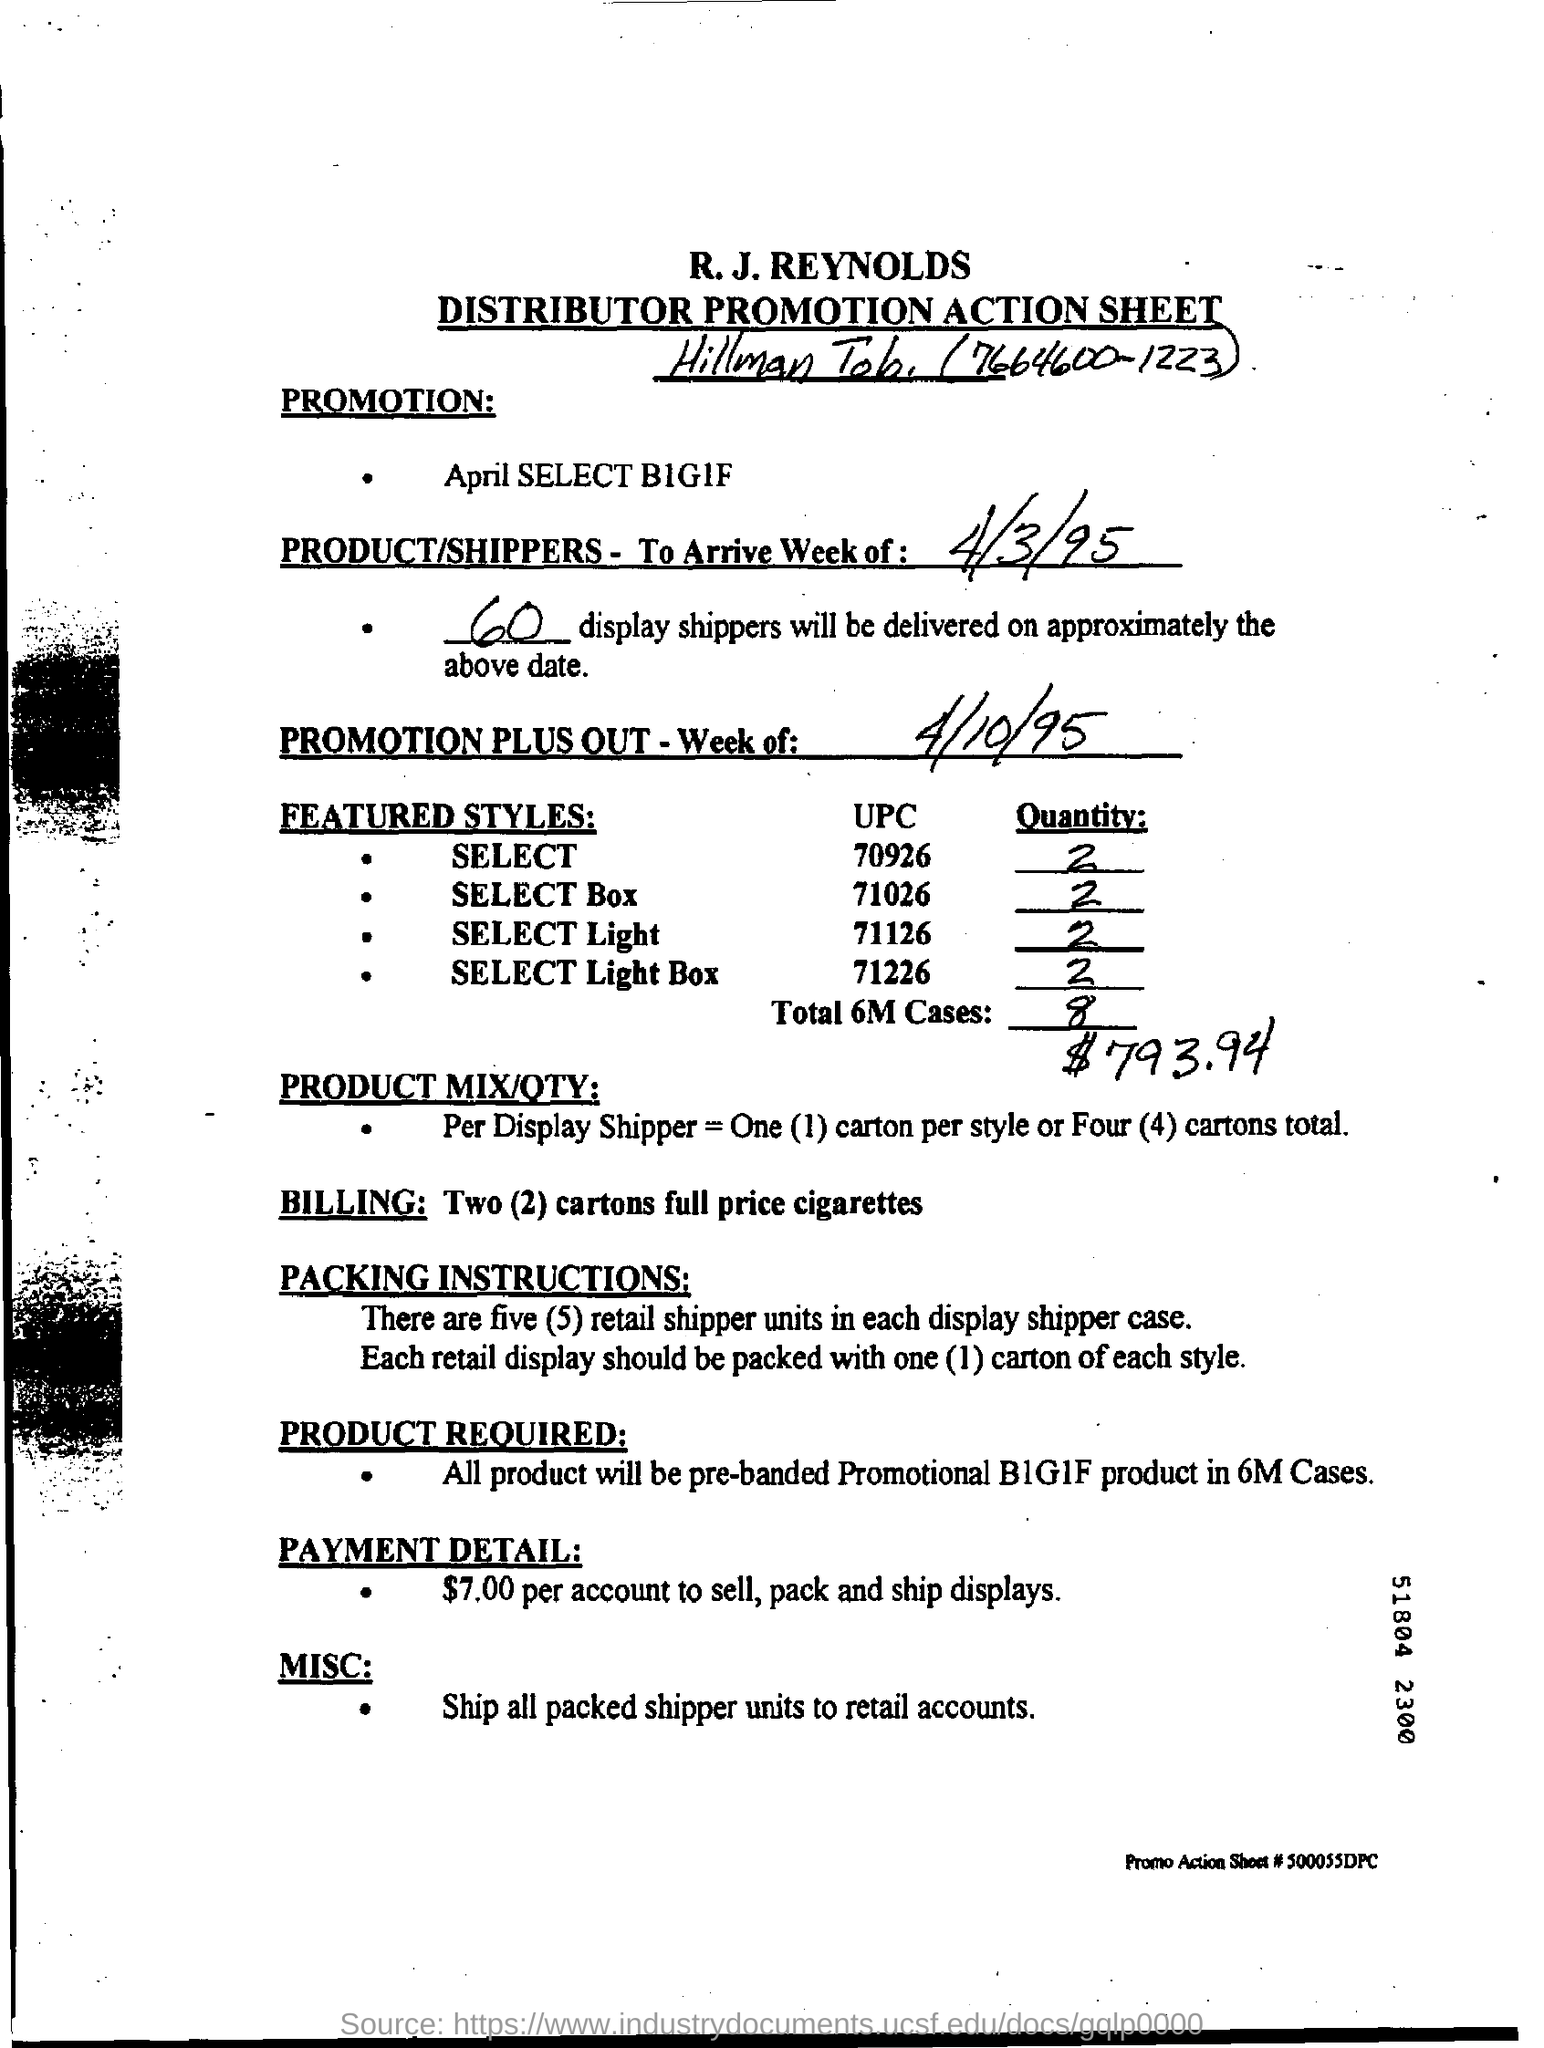Point out several critical features in this image. The payment detail given in the form is $7.00 per account to sell, pack, and ship displays. The second title in the document is 'Distributor Promotion Action Sheet.' 